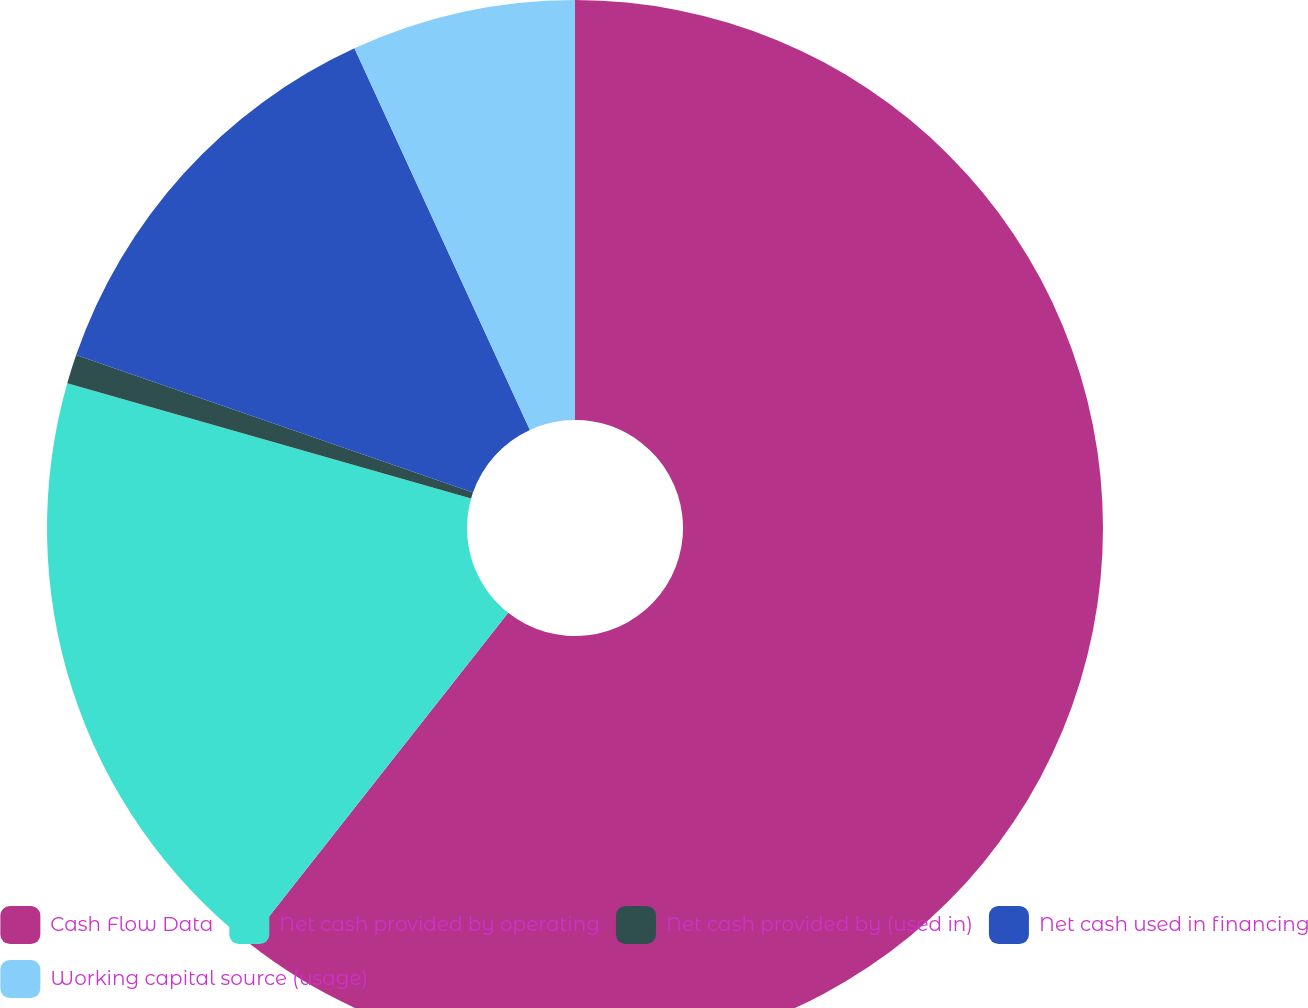Convert chart. <chart><loc_0><loc_0><loc_500><loc_500><pie_chart><fcel>Cash Flow Data<fcel>Net cash provided by operating<fcel>Net cash provided by (used in)<fcel>Net cash used in financing<fcel>Working capital source (usage)<nl><fcel>60.62%<fcel>18.81%<fcel>0.89%<fcel>12.83%<fcel>6.86%<nl></chart> 